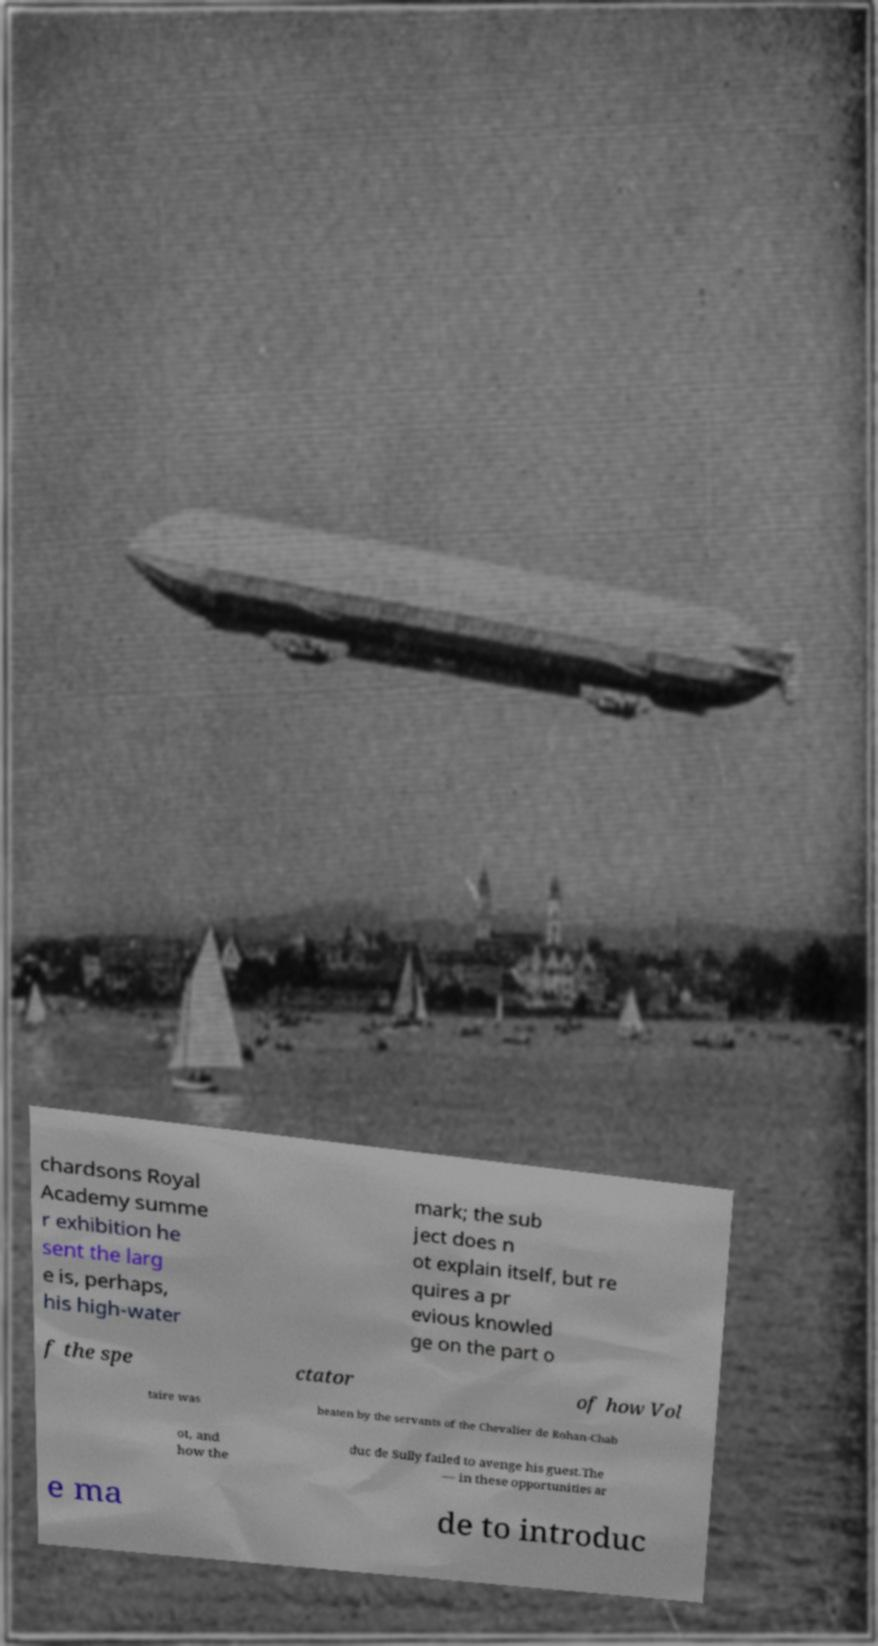Please read and relay the text visible in this image. What does it say? chardsons Royal Academy summe r exhibition he sent the larg e is, perhaps, his high-water mark; the sub ject does n ot explain itself, but re quires a pr evious knowled ge on the part o f the spe ctator of how Vol taire was beaten by the servants of the Chevalier de Rohan-Chab ot, and how the duc de Sully failed to avenge his guest.The — in these opportunities ar e ma de to introduc 